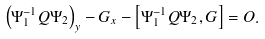Convert formula to latex. <formula><loc_0><loc_0><loc_500><loc_500>\left ( \Psi _ { 1 } ^ { - 1 } Q \Psi _ { 2 } \right ) _ { y } - G _ { x } - \left [ \Psi _ { 1 } ^ { - 1 } Q \Psi _ { 2 } , G \right ] = O .</formula> 